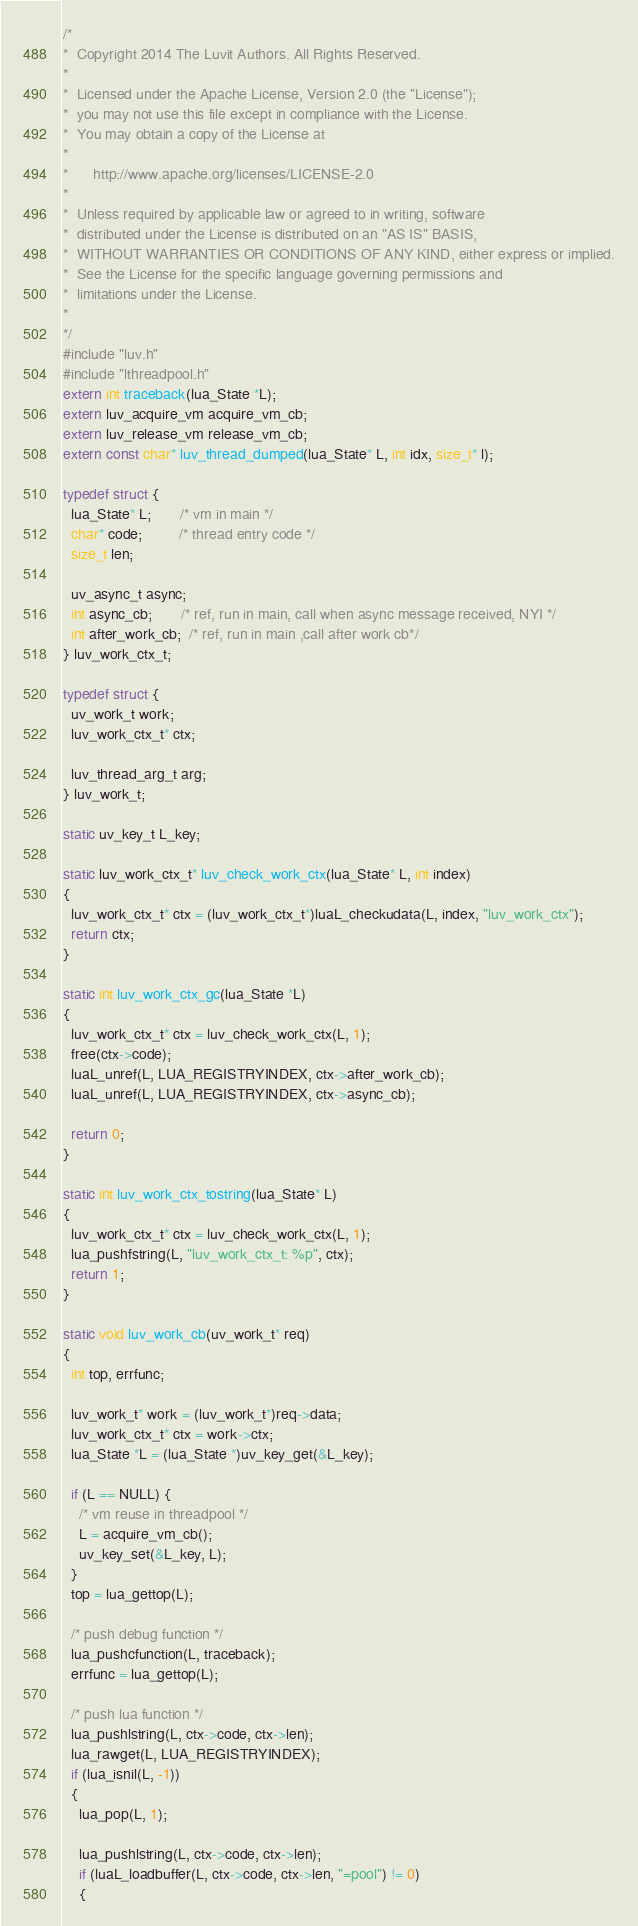<code> <loc_0><loc_0><loc_500><loc_500><_C_>/*
*  Copyright 2014 The Luvit Authors. All Rights Reserved.
*
*  Licensed under the Apache License, Version 2.0 (the "License");
*  you may not use this file except in compliance with the License.
*  You may obtain a copy of the License at
*
*      http://www.apache.org/licenses/LICENSE-2.0
*
*  Unless required by applicable law or agreed to in writing, software
*  distributed under the License is distributed on an "AS IS" BASIS,
*  WITHOUT WARRANTIES OR CONDITIONS OF ANY KIND, either express or implied.
*  See the License for the specific language governing permissions and
*  limitations under the License.
*
*/
#include "luv.h"
#include "lthreadpool.h"
extern int traceback(lua_State *L);
extern luv_acquire_vm acquire_vm_cb;
extern luv_release_vm release_vm_cb;
extern const char* luv_thread_dumped(lua_State* L, int idx, size_t* l);

typedef struct {
  lua_State* L;       /* vm in main */
  char* code;         /* thread entry code */
  size_t len;

  uv_async_t async;
  int async_cb;       /* ref, run in main, call when async message received, NYI */
  int after_work_cb;  /* ref, run in main ,call after work cb*/
} luv_work_ctx_t;

typedef struct {
  uv_work_t work;
  luv_work_ctx_t* ctx;

  luv_thread_arg_t arg;
} luv_work_t;

static uv_key_t L_key;

static luv_work_ctx_t* luv_check_work_ctx(lua_State* L, int index)
{
  luv_work_ctx_t* ctx = (luv_work_ctx_t*)luaL_checkudata(L, index, "luv_work_ctx");
  return ctx;
}

static int luv_work_ctx_gc(lua_State *L)
{
  luv_work_ctx_t* ctx = luv_check_work_ctx(L, 1);
  free(ctx->code);
  luaL_unref(L, LUA_REGISTRYINDEX, ctx->after_work_cb);
  luaL_unref(L, LUA_REGISTRYINDEX, ctx->async_cb);

  return 0;
}

static int luv_work_ctx_tostring(lua_State* L)
{
  luv_work_ctx_t* ctx = luv_check_work_ctx(L, 1);
  lua_pushfstring(L, "luv_work_ctx_t: %p", ctx);
  return 1;
}

static void luv_work_cb(uv_work_t* req)
{
  int top, errfunc;

  luv_work_t* work = (luv_work_t*)req->data;
  luv_work_ctx_t* ctx = work->ctx;
  lua_State *L = (lua_State *)uv_key_get(&L_key);

  if (L == NULL) {
    /* vm reuse in threadpool */
    L = acquire_vm_cb();
    uv_key_set(&L_key, L);
  }
  top = lua_gettop(L);

  /* push debug function */
  lua_pushcfunction(L, traceback);
  errfunc = lua_gettop(L);

  /* push lua function */
  lua_pushlstring(L, ctx->code, ctx->len);
  lua_rawget(L, LUA_REGISTRYINDEX);
  if (lua_isnil(L, -1))
  {
    lua_pop(L, 1);
    
    lua_pushlstring(L, ctx->code, ctx->len);
    if (luaL_loadbuffer(L, ctx->code, ctx->len, "=pool") != 0)
    {</code> 